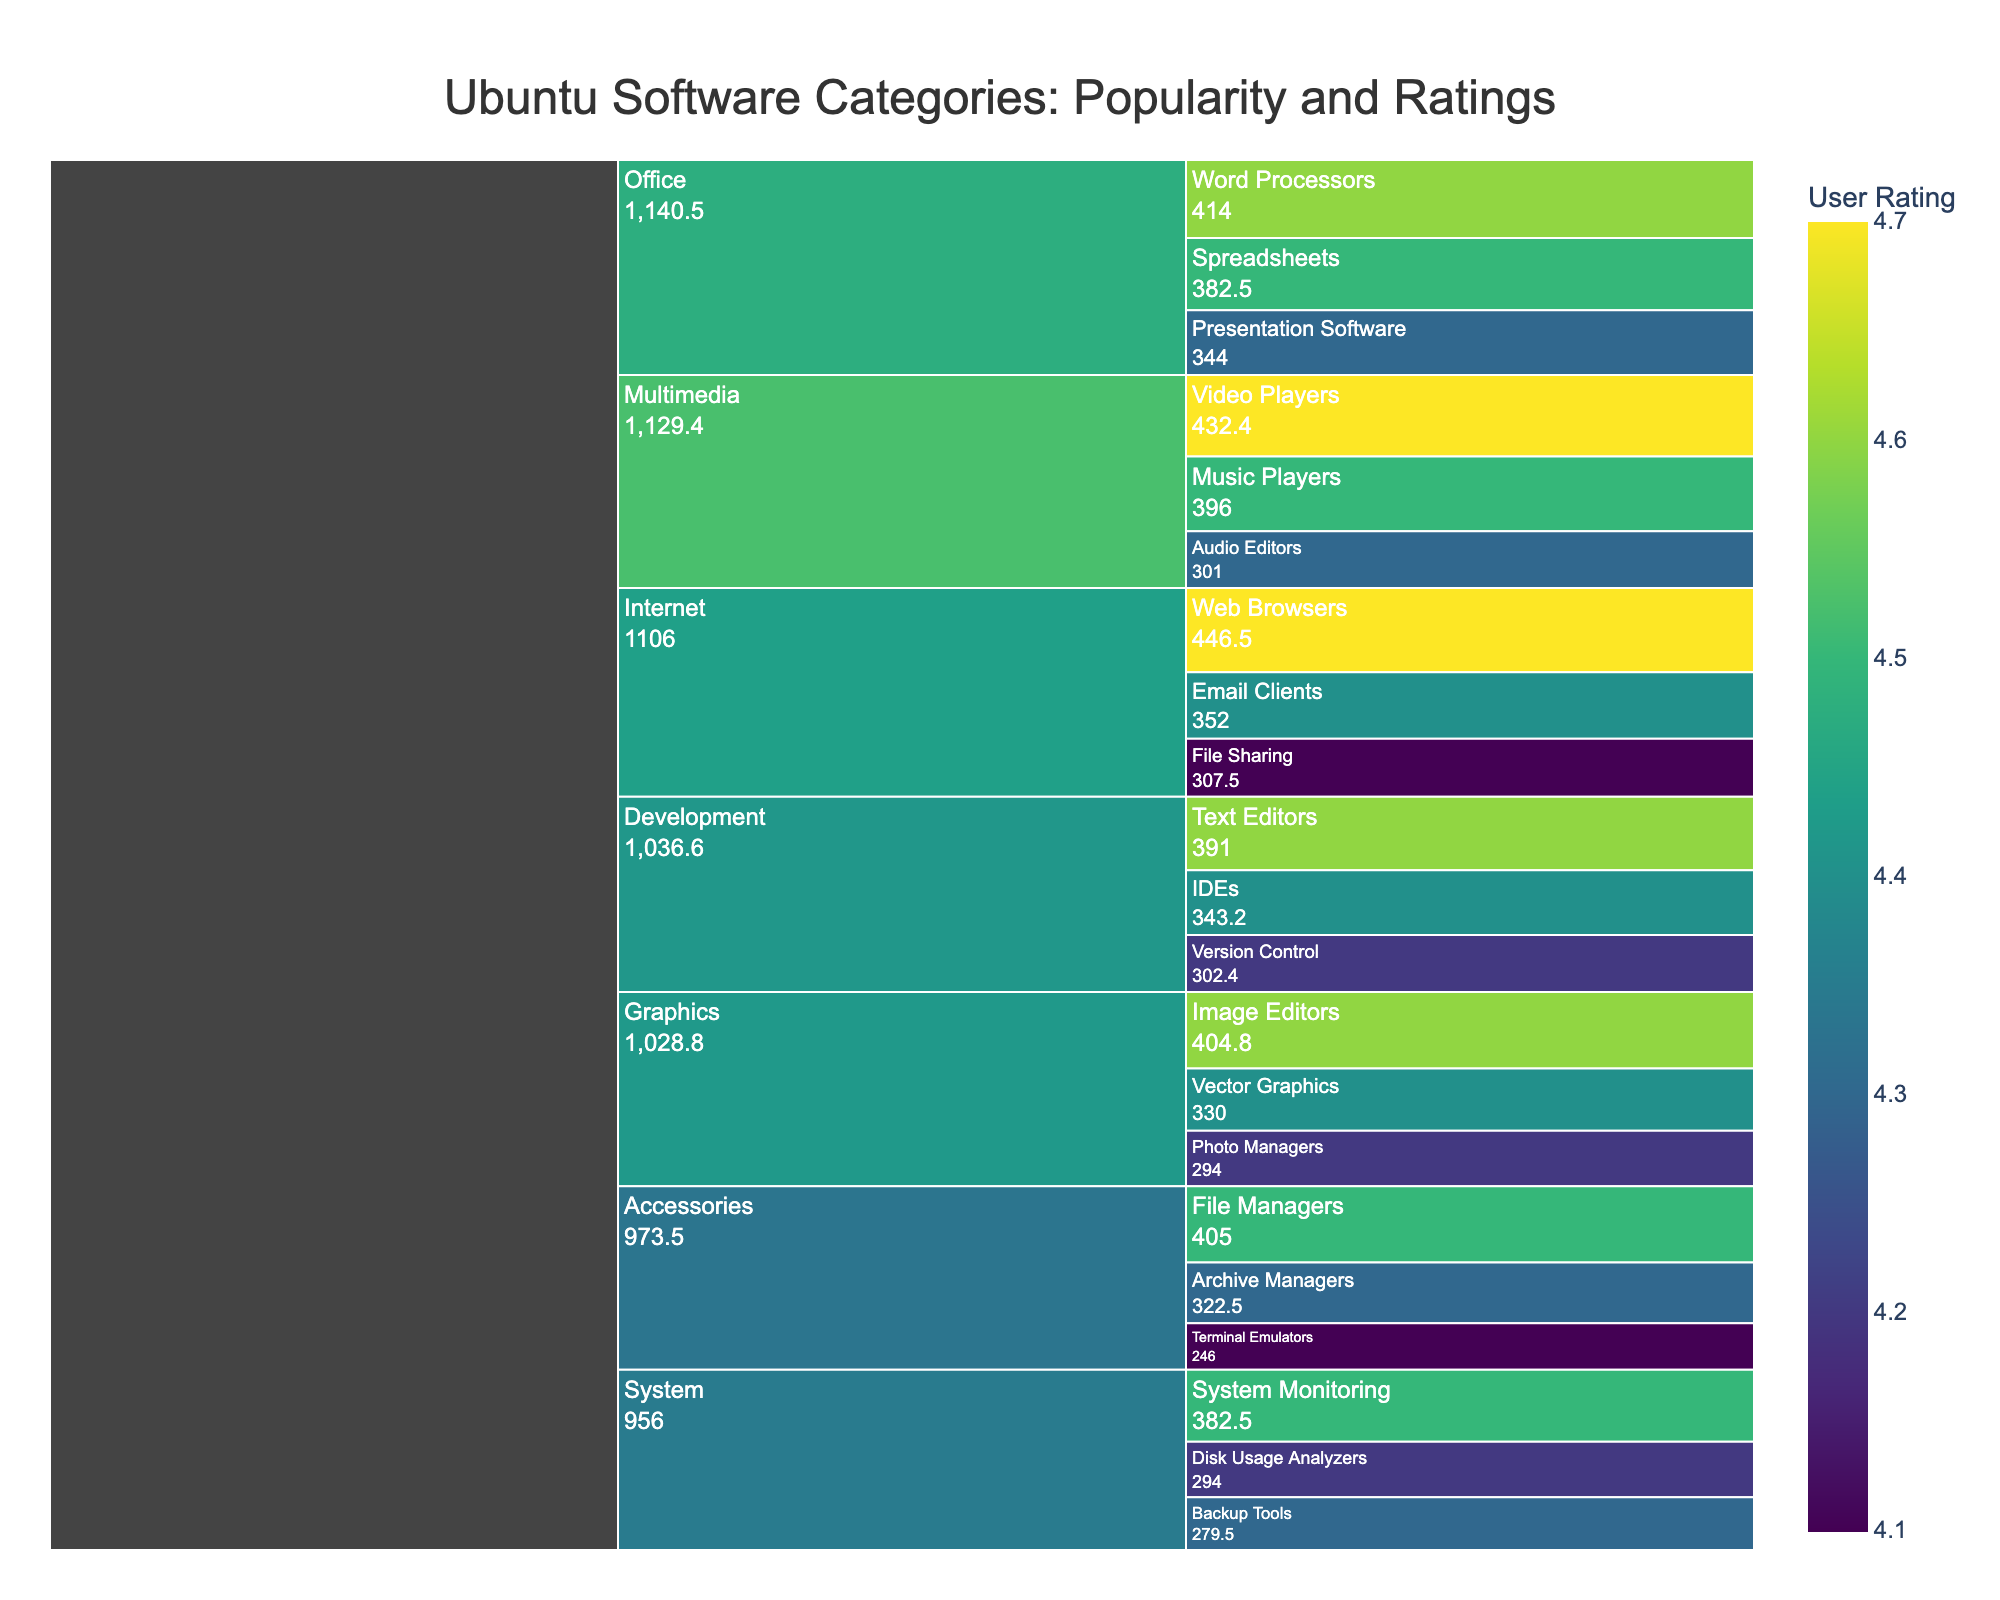What is the highest-rated subcategory in the "Multimedia" category? To find this, look at the subcategories under "Multimedia" and identify the one with the highest rating. You can see that "Video Players" has a rating of 4.7, which is the highest.
Answer: Video Players How many subcategories are there in the "Development" category? Identify the number of unique subcategories listed under "Development". You'll see "IDEs", "Text Editors", and "Version Control", totaling three subcategories.
Answer: 3 Which subcategory has both high popularity and the highest rating in the "Internet" category? Examine the subcategories under "Internet" and compare their popularity and ratings. "Web Browsers" has a popularity of 95 and a rating of 4.7, both the highest in their group.
Answer: Web Browsers What is the combined value for the subcategories in the "Office" category? Calculate the "value" for each subcategory in "Office" by multiplying their popularity by rating, then sum them. (90*4.6) + (85*4.5) + (80*4.3) = 414 + 382.5 + 344 = 1140.5
Answer: 1140.5 Which subcategory in "Graphics" has the lowest rating? Look at the subcategories under "Graphics" and identify the one with the lowest rating. "Photo Managers" has the lowest rating of 4.2.
Answer: Photo Managers How does the popularity of "Text Editors" compare to that of "File Managers"? Compare the popularity values of "Text Editors" under "Development" and "File Managers" under "Accessories". "Text Editors" has a popularity of 85, while "File Managers" has 90, so "File Managers" is more popular.
Answer: File Managers is more popular What is the average rating of subcategories in the "System" category? Add the ratings of all subcategories in "System" and divide by the number of subcategories. (4.5 + 4.2 + 4.3) / 3 = 13.0 / 3 = 4.33.
Answer: 4.33 Identify the subcategory with the highest value in the chart. Calculate the value for each subcategory (popularity * rating) and determine the highest one. "Web Browsers" has the highest value of 95 * 4.7 = 446.5.
Answer: Web Browsers What subcategory in "Accessories" has the lowest popularity? Look at the subcategories under "Accessories" and identify the one with the lowest popularity. "Terminal Emulators" has the lowest popularity of 60.
Answer: Terminal Emulators Which category has the highest sum of values for its subcategories? Calculate the sum of values for each category's subcategories and compare them. "Office" has the highest sum: (414 + 382.5 + 344) = 1140.5.
Answer: Office 